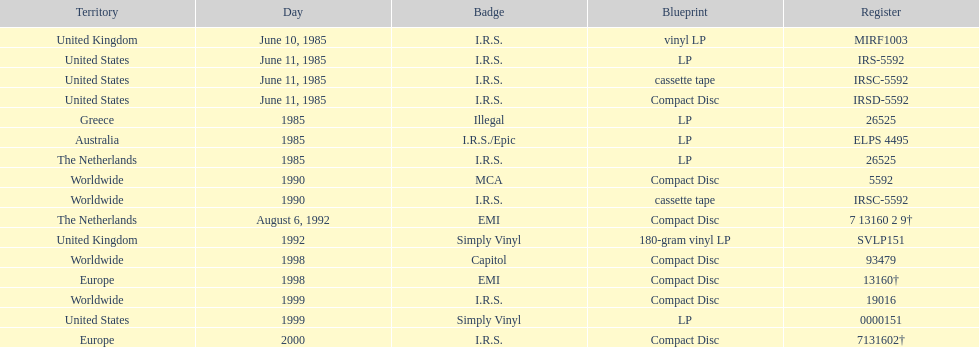What is the sole area with vinyl lp format? United Kingdom. 